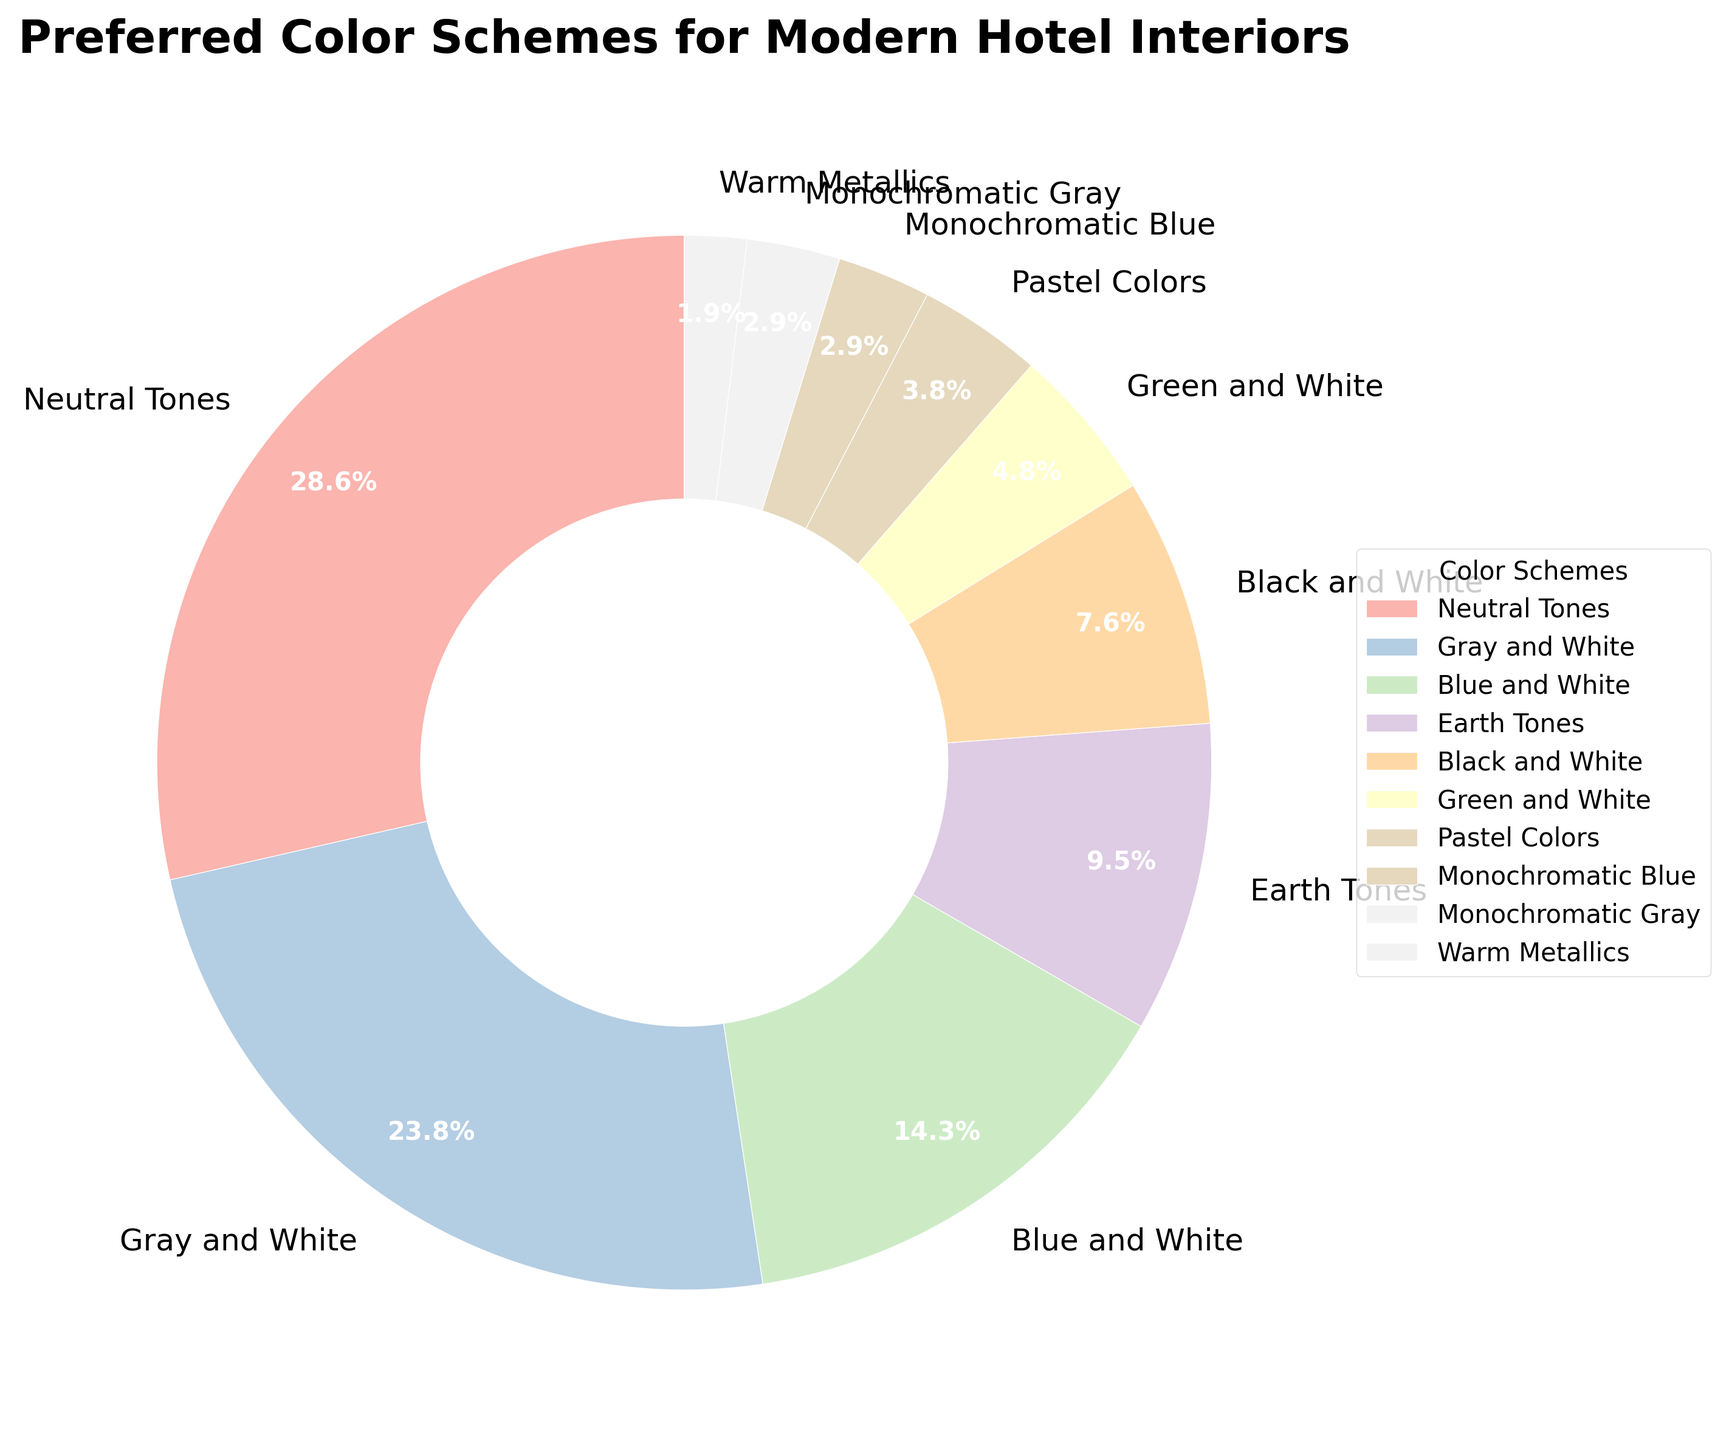What color scheme has the highest percentage? The color scheme with the highest percentage can be determined by looking at the segment of the pie chart with the largest area. The biggest wedge is labeled "Neutral Tones."
Answer: Neutral Tones Which two color schemes combined make up 40%? To find two combined color schemes that add up to 40%, look at their percentages and sum them. "Gray and White" is 25% and "Blue and White" is 15%. 25% + 15% = 40%.
Answer: Gray and White and Blue and White What is the combined percentage of Earth Tones and Warm Metallics? Look at the percentages for "Earth Tones" (10%) and "Warm Metallics" (2%). Their combined percentage is calculated by adding them together: 10% + 2% = 12%.
Answer: 12% Which color scheme has almost half the percentage of Neutral Tones? The percentage for "Neutral Tones" is 30%. Half of 30% is 15%. "Blue and White" has a percentage of 15%, which is exactly half of 30%.
Answer: Blue and White Are there more guests who prefer Earth Tones than those who prefer Black and White? The figure shows "Earth Tones" at 10% and "Black and White" at 8%. Since 10% is greater than 8%, more guests prefer Earth Tones.
Answer: Yes What percentage of guests prefer Green and White over Pastel Colors? Look at the percentages for "Green and White" (5%) and "Pastel Colors" (4%). Subtract to find the percentage difference: 5% - 4% = 1%.
Answer: 1% Which two monochromatic color schemes are equally preferred? Identify the monochromatic color schemes, "Monochromatic Blue" and "Monochromatic Gray," both of which have a percentage of 3%.
Answer: Monochromatic Blue and Monochromatic Gray What color schemes make up the smallest combined percentage? Identify the schemes with lowest individual percentages: "Warm Metallics" (2%), "Monochromatic Blue" (3%), and "Monochromatic Gray" (3%). Their combined percentage is 2% + 3% + 3% = 8%.
Answer: Warm Metallics, Monochromatic Blue, and Monochromatic Gray What is the total percentage for all color schemes that use white? Sum the percentages for "Gray and White" (25%), "Blue and White" (15%), "Green and White" (5%), and "Black and White" (8%). The total percentage is 25% + 15% + 5% + 8% = 53%.
Answer: 53% 